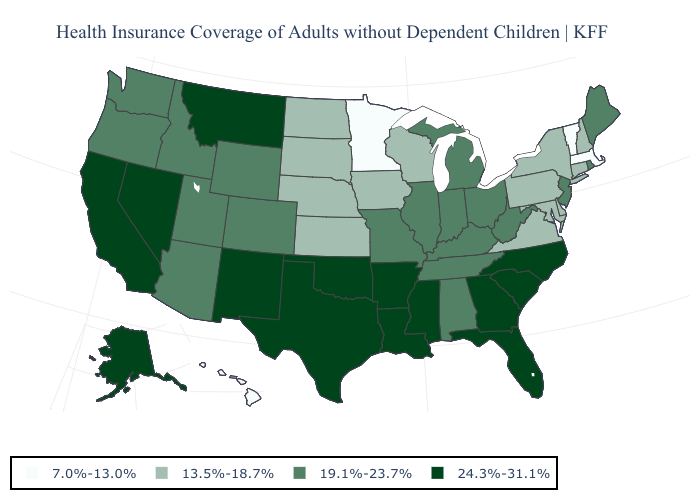Is the legend a continuous bar?
Give a very brief answer. No. What is the value of Utah?
Short answer required. 19.1%-23.7%. Name the states that have a value in the range 7.0%-13.0%?
Be succinct. Hawaii, Massachusetts, Minnesota, Vermont. Name the states that have a value in the range 24.3%-31.1%?
Answer briefly. Alaska, Arkansas, California, Florida, Georgia, Louisiana, Mississippi, Montana, Nevada, New Mexico, North Carolina, Oklahoma, South Carolina, Texas. Which states have the highest value in the USA?
Be succinct. Alaska, Arkansas, California, Florida, Georgia, Louisiana, Mississippi, Montana, Nevada, New Mexico, North Carolina, Oklahoma, South Carolina, Texas. Among the states that border Missouri , which have the lowest value?
Keep it brief. Iowa, Kansas, Nebraska. Does Wyoming have a lower value than Georgia?
Be succinct. Yes. Name the states that have a value in the range 7.0%-13.0%?
Keep it brief. Hawaii, Massachusetts, Minnesota, Vermont. What is the highest value in the MidWest ?
Keep it brief. 19.1%-23.7%. How many symbols are there in the legend?
Write a very short answer. 4. What is the lowest value in states that border Kansas?
Short answer required. 13.5%-18.7%. Name the states that have a value in the range 7.0%-13.0%?
Write a very short answer. Hawaii, Massachusetts, Minnesota, Vermont. Does Colorado have a lower value than Maryland?
Be succinct. No. Name the states that have a value in the range 7.0%-13.0%?
Concise answer only. Hawaii, Massachusetts, Minnesota, Vermont. Does Florida have the highest value in the USA?
Be succinct. Yes. 